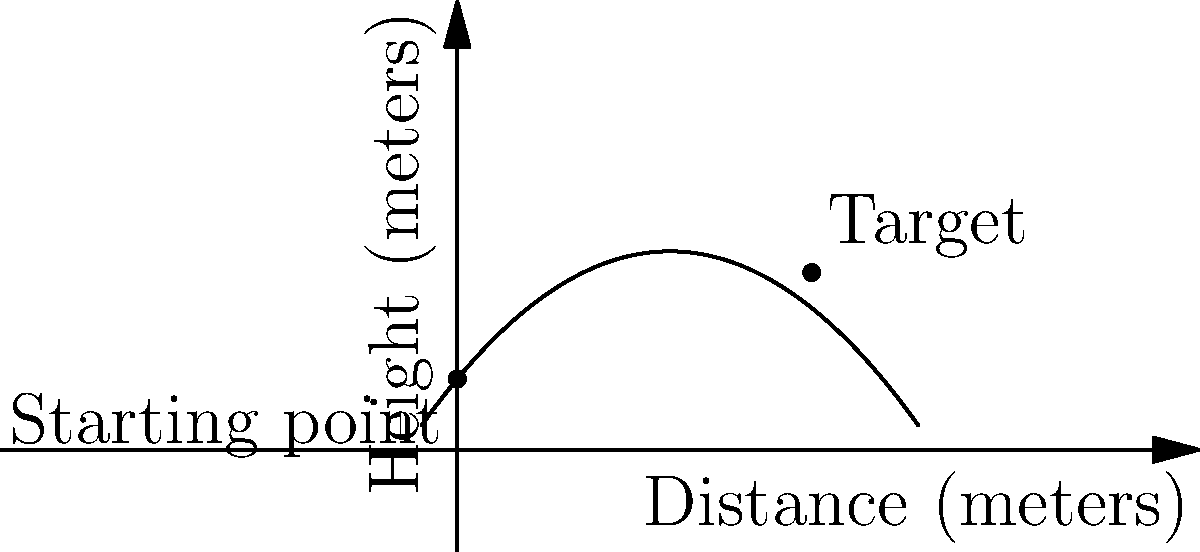A chef is demonstrating knife-throwing techniques to culinary students. The trajectory of the knife can be modeled by the function $h(x) = -0.1x^2 + 1.2x + 2$, where $h$ is the height in meters and $x$ is the horizontal distance in meters. If the chef aims to hit a target 10 meters away, what is the height of the knife at the target? To find the height of the knife at the target, we need to follow these steps:

1) The function given is $h(x) = -0.1x^2 + 1.2x + 2$

2) We need to find $h(10)$ since the target is 10 meters away

3) Let's substitute $x = 10$ into the function:

   $h(10) = -0.1(10)^2 + 1.2(10) + 2$

4) Now let's calculate step by step:
   
   $h(10) = -0.1(100) + 12 + 2$
   
   $h(10) = -10 + 12 + 2$
   
   $h(10) = 4 + 2 = 6$

5) Therefore, the height of the knife at the target is 5 meters.
Answer: 5 meters 